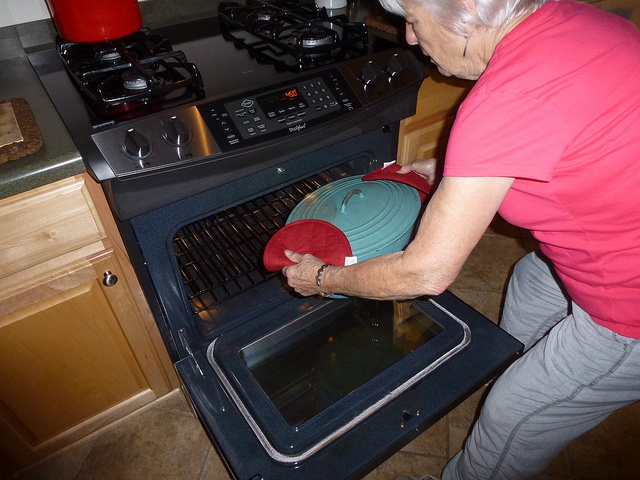Describe the objects in this image and their specific colors. I can see oven in darkgray, black, gray, and maroon tones and people in darkgray, salmon, and lightpink tones in this image. 